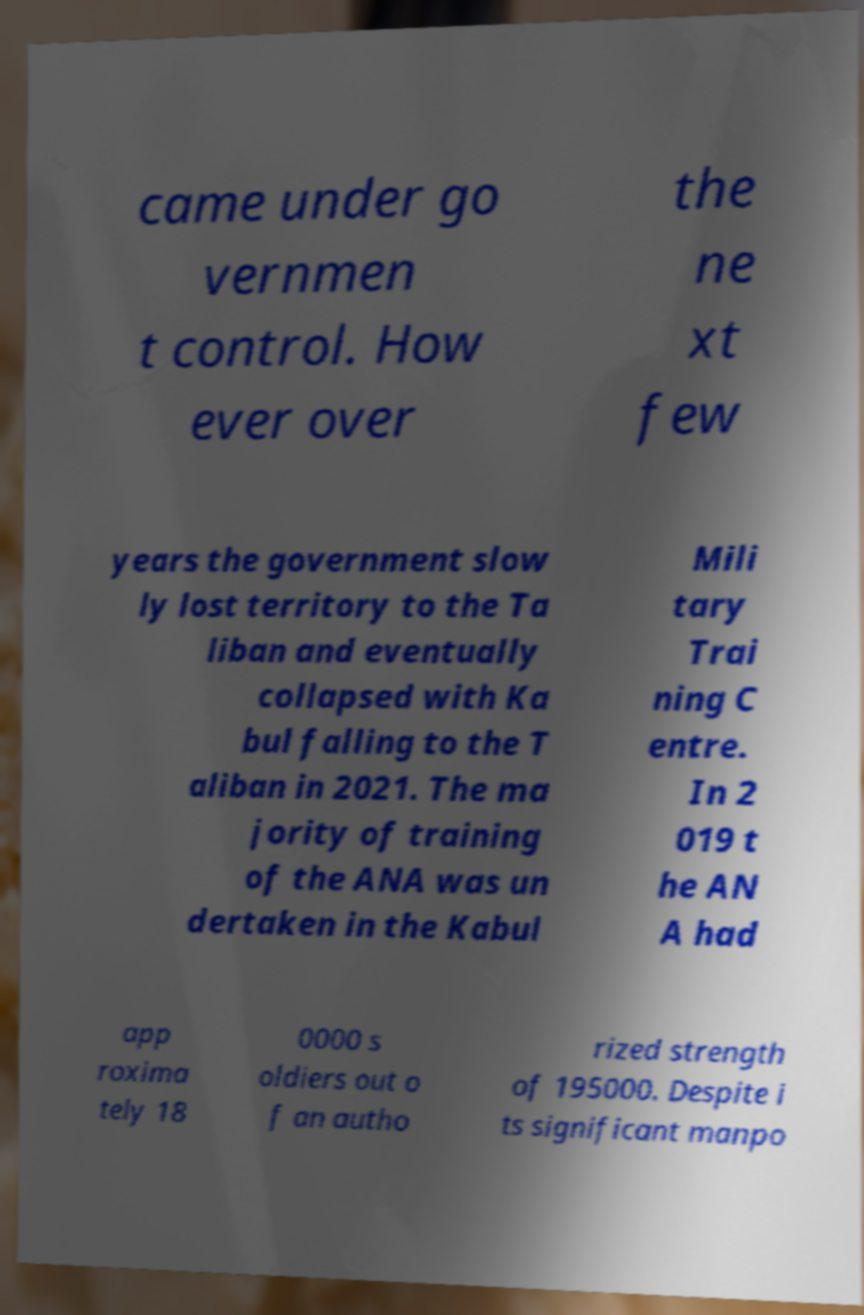For documentation purposes, I need the text within this image transcribed. Could you provide that? came under go vernmen t control. How ever over the ne xt few years the government slow ly lost territory to the Ta liban and eventually collapsed with Ka bul falling to the T aliban in 2021. The ma jority of training of the ANA was un dertaken in the Kabul Mili tary Trai ning C entre. In 2 019 t he AN A had app roxima tely 18 0000 s oldiers out o f an autho rized strength of 195000. Despite i ts significant manpo 